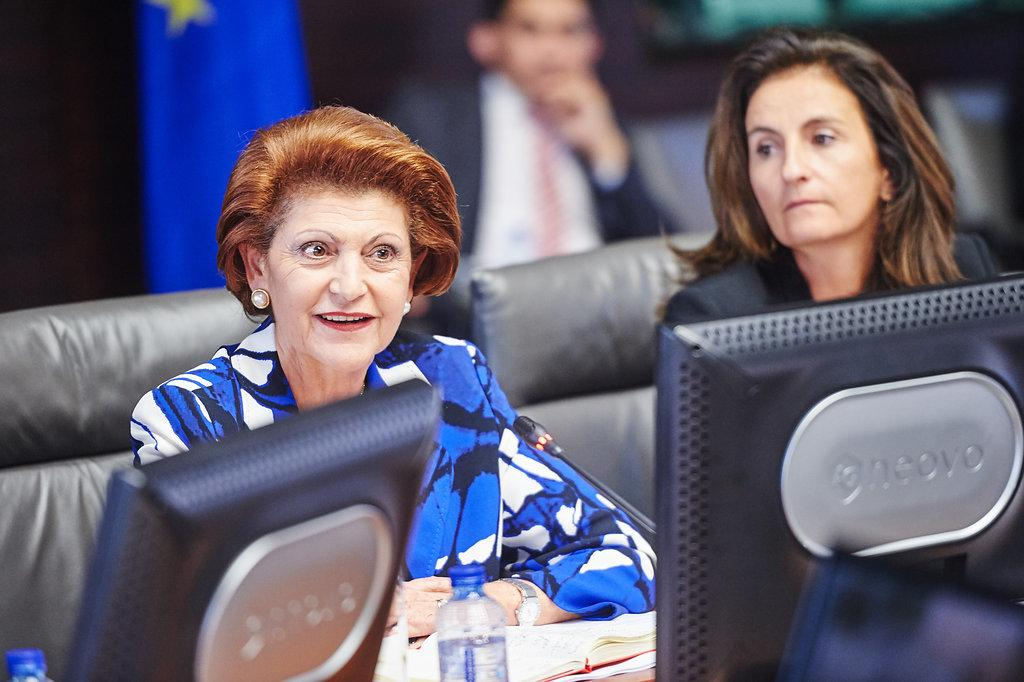How many women are sitting in the image? There are 2 women sitting in the image. What are the women doing in the image? The women are sitting in front of monitors. What objects are placed in front of the women? There is a book and water bottles in front of the women. What can be seen in the background of the image? There is a flag and a person at the back of the women. Are the women playing a harmonious tune on the instruments in the image? There are no instruments present in the image, so the women cannot be playing a harmonious tune. 